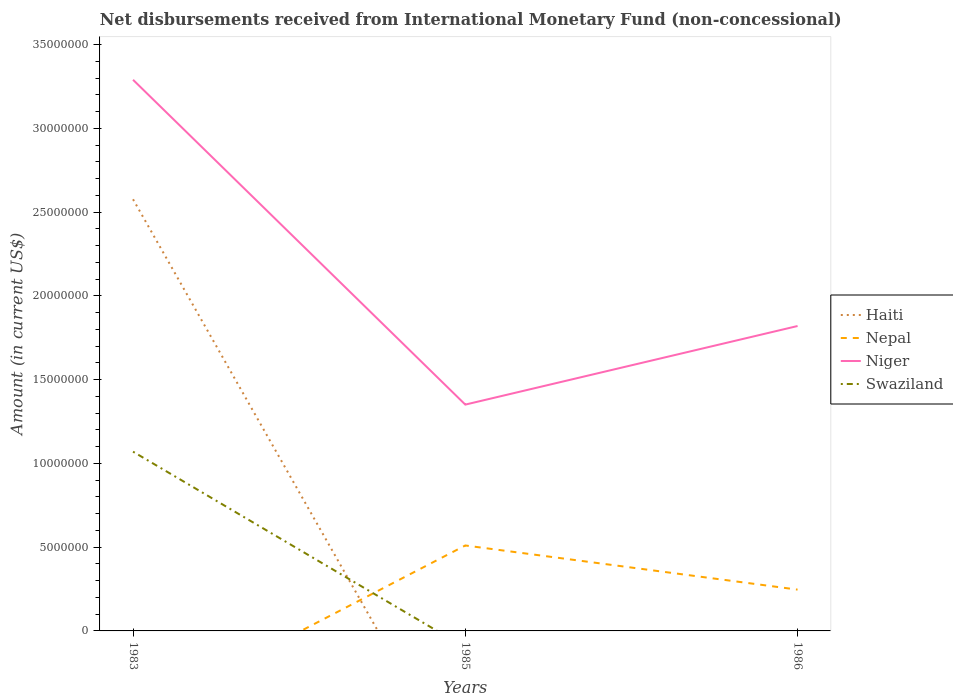Across all years, what is the maximum amount of disbursements received from International Monetary Fund in Haiti?
Offer a terse response. 0. What is the total amount of disbursements received from International Monetary Fund in Nepal in the graph?
Your answer should be very brief. 2.64e+06. What is the difference between the highest and the second highest amount of disbursements received from International Monetary Fund in Haiti?
Make the answer very short. 2.58e+07. What is the difference between the highest and the lowest amount of disbursements received from International Monetary Fund in Swaziland?
Give a very brief answer. 1. How many lines are there?
Offer a terse response. 4. What is the difference between two consecutive major ticks on the Y-axis?
Your answer should be compact. 5.00e+06. Does the graph contain grids?
Provide a succinct answer. No. What is the title of the graph?
Your response must be concise. Net disbursements received from International Monetary Fund (non-concessional). What is the label or title of the X-axis?
Your answer should be compact. Years. What is the Amount (in current US$) of Haiti in 1983?
Ensure brevity in your answer.  2.58e+07. What is the Amount (in current US$) in Niger in 1983?
Your response must be concise. 3.29e+07. What is the Amount (in current US$) of Swaziland in 1983?
Keep it short and to the point. 1.07e+07. What is the Amount (in current US$) in Nepal in 1985?
Your answer should be compact. 5.10e+06. What is the Amount (in current US$) of Niger in 1985?
Offer a very short reply. 1.35e+07. What is the Amount (in current US$) of Swaziland in 1985?
Offer a terse response. 0. What is the Amount (in current US$) of Haiti in 1986?
Provide a short and direct response. 0. What is the Amount (in current US$) in Nepal in 1986?
Offer a terse response. 2.46e+06. What is the Amount (in current US$) in Niger in 1986?
Keep it short and to the point. 1.82e+07. Across all years, what is the maximum Amount (in current US$) of Haiti?
Offer a very short reply. 2.58e+07. Across all years, what is the maximum Amount (in current US$) of Nepal?
Your answer should be compact. 5.10e+06. Across all years, what is the maximum Amount (in current US$) of Niger?
Ensure brevity in your answer.  3.29e+07. Across all years, what is the maximum Amount (in current US$) in Swaziland?
Your answer should be compact. 1.07e+07. Across all years, what is the minimum Amount (in current US$) of Haiti?
Provide a succinct answer. 0. Across all years, what is the minimum Amount (in current US$) in Niger?
Provide a short and direct response. 1.35e+07. What is the total Amount (in current US$) in Haiti in the graph?
Ensure brevity in your answer.  2.58e+07. What is the total Amount (in current US$) in Nepal in the graph?
Your response must be concise. 7.57e+06. What is the total Amount (in current US$) of Niger in the graph?
Give a very brief answer. 6.46e+07. What is the total Amount (in current US$) of Swaziland in the graph?
Provide a short and direct response. 1.07e+07. What is the difference between the Amount (in current US$) of Niger in 1983 and that in 1985?
Provide a succinct answer. 1.94e+07. What is the difference between the Amount (in current US$) of Niger in 1983 and that in 1986?
Keep it short and to the point. 1.47e+07. What is the difference between the Amount (in current US$) of Nepal in 1985 and that in 1986?
Give a very brief answer. 2.64e+06. What is the difference between the Amount (in current US$) in Niger in 1985 and that in 1986?
Keep it short and to the point. -4.69e+06. What is the difference between the Amount (in current US$) of Haiti in 1983 and the Amount (in current US$) of Nepal in 1985?
Offer a terse response. 2.07e+07. What is the difference between the Amount (in current US$) of Haiti in 1983 and the Amount (in current US$) of Niger in 1985?
Provide a succinct answer. 1.23e+07. What is the difference between the Amount (in current US$) in Haiti in 1983 and the Amount (in current US$) in Nepal in 1986?
Your answer should be very brief. 2.33e+07. What is the difference between the Amount (in current US$) in Haiti in 1983 and the Amount (in current US$) in Niger in 1986?
Keep it short and to the point. 7.56e+06. What is the difference between the Amount (in current US$) in Nepal in 1985 and the Amount (in current US$) in Niger in 1986?
Ensure brevity in your answer.  -1.31e+07. What is the average Amount (in current US$) of Haiti per year?
Offer a terse response. 8.59e+06. What is the average Amount (in current US$) of Nepal per year?
Offer a very short reply. 2.52e+06. What is the average Amount (in current US$) of Niger per year?
Provide a succinct answer. 2.15e+07. What is the average Amount (in current US$) of Swaziland per year?
Offer a very short reply. 3.57e+06. In the year 1983, what is the difference between the Amount (in current US$) in Haiti and Amount (in current US$) in Niger?
Provide a succinct answer. -7.13e+06. In the year 1983, what is the difference between the Amount (in current US$) in Haiti and Amount (in current US$) in Swaziland?
Provide a short and direct response. 1.51e+07. In the year 1983, what is the difference between the Amount (in current US$) in Niger and Amount (in current US$) in Swaziland?
Offer a terse response. 2.22e+07. In the year 1985, what is the difference between the Amount (in current US$) in Nepal and Amount (in current US$) in Niger?
Offer a very short reply. -8.41e+06. In the year 1986, what is the difference between the Amount (in current US$) of Nepal and Amount (in current US$) of Niger?
Provide a succinct answer. -1.57e+07. What is the ratio of the Amount (in current US$) of Niger in 1983 to that in 1985?
Your response must be concise. 2.44. What is the ratio of the Amount (in current US$) of Niger in 1983 to that in 1986?
Your response must be concise. 1.81. What is the ratio of the Amount (in current US$) in Nepal in 1985 to that in 1986?
Provide a succinct answer. 2.07. What is the ratio of the Amount (in current US$) of Niger in 1985 to that in 1986?
Offer a very short reply. 0.74. What is the difference between the highest and the second highest Amount (in current US$) of Niger?
Offer a very short reply. 1.47e+07. What is the difference between the highest and the lowest Amount (in current US$) of Haiti?
Provide a short and direct response. 2.58e+07. What is the difference between the highest and the lowest Amount (in current US$) of Nepal?
Ensure brevity in your answer.  5.10e+06. What is the difference between the highest and the lowest Amount (in current US$) of Niger?
Your answer should be compact. 1.94e+07. What is the difference between the highest and the lowest Amount (in current US$) of Swaziland?
Provide a short and direct response. 1.07e+07. 